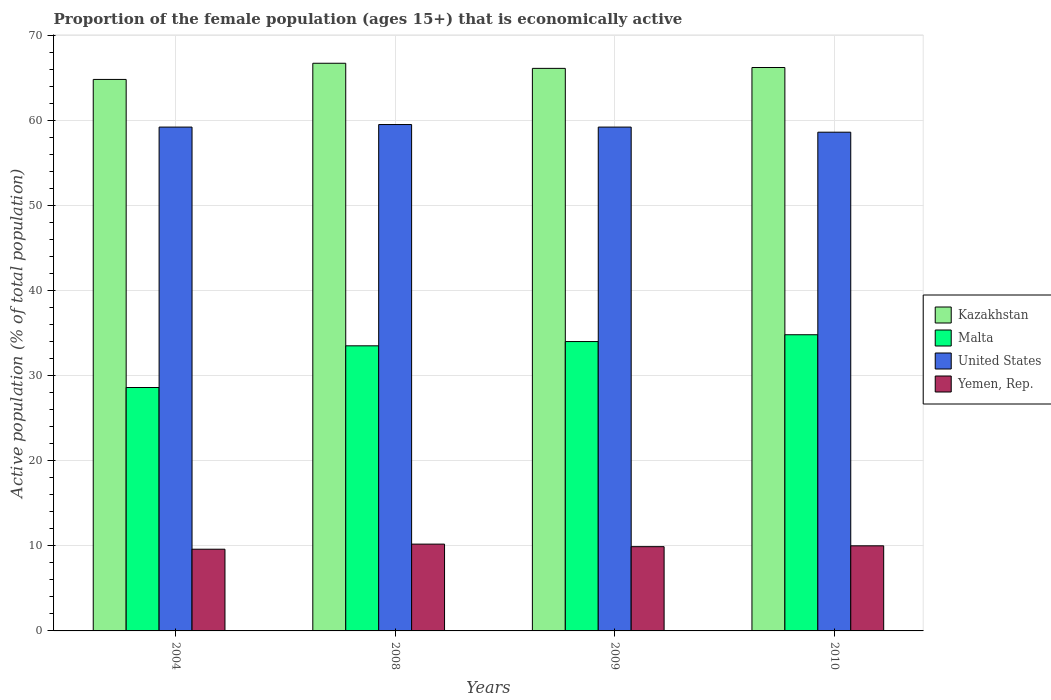How many different coloured bars are there?
Your response must be concise. 4. How many groups of bars are there?
Your response must be concise. 4. Are the number of bars per tick equal to the number of legend labels?
Give a very brief answer. Yes. Are the number of bars on each tick of the X-axis equal?
Your answer should be compact. Yes. How many bars are there on the 2nd tick from the right?
Your answer should be compact. 4. In how many cases, is the number of bars for a given year not equal to the number of legend labels?
Your answer should be very brief. 0. What is the proportion of the female population that is economically active in United States in 2008?
Offer a terse response. 59.5. Across all years, what is the maximum proportion of the female population that is economically active in Malta?
Offer a very short reply. 34.8. Across all years, what is the minimum proportion of the female population that is economically active in Kazakhstan?
Give a very brief answer. 64.8. What is the total proportion of the female population that is economically active in Yemen, Rep. in the graph?
Your answer should be compact. 39.7. What is the difference between the proportion of the female population that is economically active in Kazakhstan in 2009 and that in 2010?
Provide a short and direct response. -0.1. What is the difference between the proportion of the female population that is economically active in Malta in 2008 and the proportion of the female population that is economically active in United States in 2004?
Your answer should be compact. -25.7. What is the average proportion of the female population that is economically active in United States per year?
Your response must be concise. 59.13. In the year 2004, what is the difference between the proportion of the female population that is economically active in Malta and proportion of the female population that is economically active in Yemen, Rep.?
Offer a very short reply. 19. What is the ratio of the proportion of the female population that is economically active in Yemen, Rep. in 2008 to that in 2009?
Your response must be concise. 1.03. Is the difference between the proportion of the female population that is economically active in Malta in 2004 and 2008 greater than the difference between the proportion of the female population that is economically active in Yemen, Rep. in 2004 and 2008?
Give a very brief answer. No. What is the difference between the highest and the second highest proportion of the female population that is economically active in Malta?
Your answer should be compact. 0.8. What is the difference between the highest and the lowest proportion of the female population that is economically active in United States?
Make the answer very short. 0.9. In how many years, is the proportion of the female population that is economically active in Malta greater than the average proportion of the female population that is economically active in Malta taken over all years?
Keep it short and to the point. 3. Is the sum of the proportion of the female population that is economically active in Malta in 2004 and 2010 greater than the maximum proportion of the female population that is economically active in Yemen, Rep. across all years?
Provide a succinct answer. Yes. Is it the case that in every year, the sum of the proportion of the female population that is economically active in Kazakhstan and proportion of the female population that is economically active in Malta is greater than the sum of proportion of the female population that is economically active in Yemen, Rep. and proportion of the female population that is economically active in United States?
Keep it short and to the point. Yes. What does the 2nd bar from the left in 2010 represents?
Provide a short and direct response. Malta. What does the 2nd bar from the right in 2009 represents?
Make the answer very short. United States. Is it the case that in every year, the sum of the proportion of the female population that is economically active in Kazakhstan and proportion of the female population that is economically active in United States is greater than the proportion of the female population that is economically active in Malta?
Make the answer very short. Yes. Are all the bars in the graph horizontal?
Make the answer very short. No. Does the graph contain any zero values?
Your response must be concise. No. How many legend labels are there?
Provide a succinct answer. 4. How are the legend labels stacked?
Your answer should be compact. Vertical. What is the title of the graph?
Keep it short and to the point. Proportion of the female population (ages 15+) that is economically active. What is the label or title of the X-axis?
Offer a terse response. Years. What is the label or title of the Y-axis?
Offer a terse response. Active population (% of total population). What is the Active population (% of total population) in Kazakhstan in 2004?
Give a very brief answer. 64.8. What is the Active population (% of total population) of Malta in 2004?
Your answer should be very brief. 28.6. What is the Active population (% of total population) in United States in 2004?
Your answer should be compact. 59.2. What is the Active population (% of total population) in Yemen, Rep. in 2004?
Your response must be concise. 9.6. What is the Active population (% of total population) in Kazakhstan in 2008?
Provide a succinct answer. 66.7. What is the Active population (% of total population) in Malta in 2008?
Your answer should be compact. 33.5. What is the Active population (% of total population) in United States in 2008?
Your response must be concise. 59.5. What is the Active population (% of total population) of Yemen, Rep. in 2008?
Keep it short and to the point. 10.2. What is the Active population (% of total population) of Kazakhstan in 2009?
Your answer should be very brief. 66.1. What is the Active population (% of total population) of Malta in 2009?
Offer a terse response. 34. What is the Active population (% of total population) of United States in 2009?
Offer a terse response. 59.2. What is the Active population (% of total population) of Yemen, Rep. in 2009?
Provide a succinct answer. 9.9. What is the Active population (% of total population) of Kazakhstan in 2010?
Your response must be concise. 66.2. What is the Active population (% of total population) of Malta in 2010?
Offer a very short reply. 34.8. What is the Active population (% of total population) in United States in 2010?
Your answer should be compact. 58.6. What is the Active population (% of total population) in Yemen, Rep. in 2010?
Ensure brevity in your answer.  10. Across all years, what is the maximum Active population (% of total population) in Kazakhstan?
Provide a succinct answer. 66.7. Across all years, what is the maximum Active population (% of total population) of Malta?
Keep it short and to the point. 34.8. Across all years, what is the maximum Active population (% of total population) of United States?
Make the answer very short. 59.5. Across all years, what is the maximum Active population (% of total population) in Yemen, Rep.?
Your answer should be compact. 10.2. Across all years, what is the minimum Active population (% of total population) in Kazakhstan?
Your response must be concise. 64.8. Across all years, what is the minimum Active population (% of total population) of Malta?
Your answer should be compact. 28.6. Across all years, what is the minimum Active population (% of total population) in United States?
Provide a short and direct response. 58.6. Across all years, what is the minimum Active population (% of total population) in Yemen, Rep.?
Your answer should be very brief. 9.6. What is the total Active population (% of total population) in Kazakhstan in the graph?
Ensure brevity in your answer.  263.8. What is the total Active population (% of total population) in Malta in the graph?
Ensure brevity in your answer.  130.9. What is the total Active population (% of total population) in United States in the graph?
Keep it short and to the point. 236.5. What is the total Active population (% of total population) in Yemen, Rep. in the graph?
Your answer should be very brief. 39.7. What is the difference between the Active population (% of total population) in Kazakhstan in 2004 and that in 2008?
Give a very brief answer. -1.9. What is the difference between the Active population (% of total population) in United States in 2004 and that in 2008?
Keep it short and to the point. -0.3. What is the difference between the Active population (% of total population) of Yemen, Rep. in 2004 and that in 2008?
Provide a succinct answer. -0.6. What is the difference between the Active population (% of total population) in Malta in 2004 and that in 2009?
Ensure brevity in your answer.  -5.4. What is the difference between the Active population (% of total population) of United States in 2004 and that in 2009?
Offer a terse response. 0. What is the difference between the Active population (% of total population) in Yemen, Rep. in 2004 and that in 2009?
Your answer should be compact. -0.3. What is the difference between the Active population (% of total population) in Yemen, Rep. in 2004 and that in 2010?
Your answer should be compact. -0.4. What is the difference between the Active population (% of total population) in Kazakhstan in 2008 and that in 2009?
Ensure brevity in your answer.  0.6. What is the difference between the Active population (% of total population) in Malta in 2008 and that in 2009?
Keep it short and to the point. -0.5. What is the difference between the Active population (% of total population) of United States in 2008 and that in 2009?
Offer a very short reply. 0.3. What is the difference between the Active population (% of total population) in Yemen, Rep. in 2008 and that in 2009?
Keep it short and to the point. 0.3. What is the difference between the Active population (% of total population) of United States in 2008 and that in 2010?
Give a very brief answer. 0.9. What is the difference between the Active population (% of total population) of Kazakhstan in 2009 and that in 2010?
Make the answer very short. -0.1. What is the difference between the Active population (% of total population) of United States in 2009 and that in 2010?
Provide a succinct answer. 0.6. What is the difference between the Active population (% of total population) in Yemen, Rep. in 2009 and that in 2010?
Provide a short and direct response. -0.1. What is the difference between the Active population (% of total population) in Kazakhstan in 2004 and the Active population (% of total population) in Malta in 2008?
Ensure brevity in your answer.  31.3. What is the difference between the Active population (% of total population) in Kazakhstan in 2004 and the Active population (% of total population) in Yemen, Rep. in 2008?
Provide a succinct answer. 54.6. What is the difference between the Active population (% of total population) of Malta in 2004 and the Active population (% of total population) of United States in 2008?
Ensure brevity in your answer.  -30.9. What is the difference between the Active population (% of total population) in Kazakhstan in 2004 and the Active population (% of total population) in Malta in 2009?
Offer a very short reply. 30.8. What is the difference between the Active population (% of total population) of Kazakhstan in 2004 and the Active population (% of total population) of Yemen, Rep. in 2009?
Keep it short and to the point. 54.9. What is the difference between the Active population (% of total population) in Malta in 2004 and the Active population (% of total population) in United States in 2009?
Your answer should be very brief. -30.6. What is the difference between the Active population (% of total population) of Malta in 2004 and the Active population (% of total population) of Yemen, Rep. in 2009?
Give a very brief answer. 18.7. What is the difference between the Active population (% of total population) of United States in 2004 and the Active population (% of total population) of Yemen, Rep. in 2009?
Your answer should be very brief. 49.3. What is the difference between the Active population (% of total population) in Kazakhstan in 2004 and the Active population (% of total population) in Malta in 2010?
Your answer should be compact. 30. What is the difference between the Active population (% of total population) of Kazakhstan in 2004 and the Active population (% of total population) of United States in 2010?
Your response must be concise. 6.2. What is the difference between the Active population (% of total population) in Kazakhstan in 2004 and the Active population (% of total population) in Yemen, Rep. in 2010?
Provide a short and direct response. 54.8. What is the difference between the Active population (% of total population) of Malta in 2004 and the Active population (% of total population) of United States in 2010?
Offer a very short reply. -30. What is the difference between the Active population (% of total population) of Malta in 2004 and the Active population (% of total population) of Yemen, Rep. in 2010?
Your answer should be very brief. 18.6. What is the difference between the Active population (% of total population) of United States in 2004 and the Active population (% of total population) of Yemen, Rep. in 2010?
Provide a succinct answer. 49.2. What is the difference between the Active population (% of total population) of Kazakhstan in 2008 and the Active population (% of total population) of Malta in 2009?
Your answer should be compact. 32.7. What is the difference between the Active population (% of total population) in Kazakhstan in 2008 and the Active population (% of total population) in Yemen, Rep. in 2009?
Provide a short and direct response. 56.8. What is the difference between the Active population (% of total population) in Malta in 2008 and the Active population (% of total population) in United States in 2009?
Your answer should be very brief. -25.7. What is the difference between the Active population (% of total population) of Malta in 2008 and the Active population (% of total population) of Yemen, Rep. in 2009?
Offer a very short reply. 23.6. What is the difference between the Active population (% of total population) in United States in 2008 and the Active population (% of total population) in Yemen, Rep. in 2009?
Provide a succinct answer. 49.6. What is the difference between the Active population (% of total population) in Kazakhstan in 2008 and the Active population (% of total population) in Malta in 2010?
Your response must be concise. 31.9. What is the difference between the Active population (% of total population) of Kazakhstan in 2008 and the Active population (% of total population) of Yemen, Rep. in 2010?
Offer a very short reply. 56.7. What is the difference between the Active population (% of total population) of Malta in 2008 and the Active population (% of total population) of United States in 2010?
Provide a succinct answer. -25.1. What is the difference between the Active population (% of total population) in United States in 2008 and the Active population (% of total population) in Yemen, Rep. in 2010?
Provide a succinct answer. 49.5. What is the difference between the Active population (% of total population) in Kazakhstan in 2009 and the Active population (% of total population) in Malta in 2010?
Give a very brief answer. 31.3. What is the difference between the Active population (% of total population) of Kazakhstan in 2009 and the Active population (% of total population) of Yemen, Rep. in 2010?
Your answer should be very brief. 56.1. What is the difference between the Active population (% of total population) in Malta in 2009 and the Active population (% of total population) in United States in 2010?
Make the answer very short. -24.6. What is the difference between the Active population (% of total population) of Malta in 2009 and the Active population (% of total population) of Yemen, Rep. in 2010?
Offer a very short reply. 24. What is the difference between the Active population (% of total population) of United States in 2009 and the Active population (% of total population) of Yemen, Rep. in 2010?
Ensure brevity in your answer.  49.2. What is the average Active population (% of total population) in Kazakhstan per year?
Your answer should be compact. 65.95. What is the average Active population (% of total population) in Malta per year?
Your answer should be compact. 32.73. What is the average Active population (% of total population) in United States per year?
Provide a succinct answer. 59.12. What is the average Active population (% of total population) of Yemen, Rep. per year?
Keep it short and to the point. 9.93. In the year 2004, what is the difference between the Active population (% of total population) in Kazakhstan and Active population (% of total population) in Malta?
Provide a short and direct response. 36.2. In the year 2004, what is the difference between the Active population (% of total population) in Kazakhstan and Active population (% of total population) in United States?
Offer a terse response. 5.6. In the year 2004, what is the difference between the Active population (% of total population) of Kazakhstan and Active population (% of total population) of Yemen, Rep.?
Your answer should be very brief. 55.2. In the year 2004, what is the difference between the Active population (% of total population) of Malta and Active population (% of total population) of United States?
Offer a very short reply. -30.6. In the year 2004, what is the difference between the Active population (% of total population) of Malta and Active population (% of total population) of Yemen, Rep.?
Keep it short and to the point. 19. In the year 2004, what is the difference between the Active population (% of total population) of United States and Active population (% of total population) of Yemen, Rep.?
Provide a succinct answer. 49.6. In the year 2008, what is the difference between the Active population (% of total population) in Kazakhstan and Active population (% of total population) in Malta?
Your response must be concise. 33.2. In the year 2008, what is the difference between the Active population (% of total population) in Kazakhstan and Active population (% of total population) in Yemen, Rep.?
Give a very brief answer. 56.5. In the year 2008, what is the difference between the Active population (% of total population) of Malta and Active population (% of total population) of Yemen, Rep.?
Your response must be concise. 23.3. In the year 2008, what is the difference between the Active population (% of total population) in United States and Active population (% of total population) in Yemen, Rep.?
Offer a very short reply. 49.3. In the year 2009, what is the difference between the Active population (% of total population) in Kazakhstan and Active population (% of total population) in Malta?
Give a very brief answer. 32.1. In the year 2009, what is the difference between the Active population (% of total population) in Kazakhstan and Active population (% of total population) in United States?
Give a very brief answer. 6.9. In the year 2009, what is the difference between the Active population (% of total population) in Kazakhstan and Active population (% of total population) in Yemen, Rep.?
Ensure brevity in your answer.  56.2. In the year 2009, what is the difference between the Active population (% of total population) of Malta and Active population (% of total population) of United States?
Give a very brief answer. -25.2. In the year 2009, what is the difference between the Active population (% of total population) of Malta and Active population (% of total population) of Yemen, Rep.?
Offer a terse response. 24.1. In the year 2009, what is the difference between the Active population (% of total population) of United States and Active population (% of total population) of Yemen, Rep.?
Give a very brief answer. 49.3. In the year 2010, what is the difference between the Active population (% of total population) in Kazakhstan and Active population (% of total population) in Malta?
Offer a terse response. 31.4. In the year 2010, what is the difference between the Active population (% of total population) of Kazakhstan and Active population (% of total population) of United States?
Your answer should be compact. 7.6. In the year 2010, what is the difference between the Active population (% of total population) of Kazakhstan and Active population (% of total population) of Yemen, Rep.?
Provide a succinct answer. 56.2. In the year 2010, what is the difference between the Active population (% of total population) in Malta and Active population (% of total population) in United States?
Give a very brief answer. -23.8. In the year 2010, what is the difference between the Active population (% of total population) in Malta and Active population (% of total population) in Yemen, Rep.?
Your answer should be compact. 24.8. In the year 2010, what is the difference between the Active population (% of total population) in United States and Active population (% of total population) in Yemen, Rep.?
Provide a succinct answer. 48.6. What is the ratio of the Active population (% of total population) in Kazakhstan in 2004 to that in 2008?
Give a very brief answer. 0.97. What is the ratio of the Active population (% of total population) of Malta in 2004 to that in 2008?
Your answer should be compact. 0.85. What is the ratio of the Active population (% of total population) in Yemen, Rep. in 2004 to that in 2008?
Your answer should be compact. 0.94. What is the ratio of the Active population (% of total population) of Kazakhstan in 2004 to that in 2009?
Keep it short and to the point. 0.98. What is the ratio of the Active population (% of total population) of Malta in 2004 to that in 2009?
Your response must be concise. 0.84. What is the ratio of the Active population (% of total population) of United States in 2004 to that in 2009?
Keep it short and to the point. 1. What is the ratio of the Active population (% of total population) of Yemen, Rep. in 2004 to that in 2009?
Ensure brevity in your answer.  0.97. What is the ratio of the Active population (% of total population) of Kazakhstan in 2004 to that in 2010?
Your answer should be very brief. 0.98. What is the ratio of the Active population (% of total population) in Malta in 2004 to that in 2010?
Your response must be concise. 0.82. What is the ratio of the Active population (% of total population) in United States in 2004 to that in 2010?
Provide a short and direct response. 1.01. What is the ratio of the Active population (% of total population) in Yemen, Rep. in 2004 to that in 2010?
Offer a terse response. 0.96. What is the ratio of the Active population (% of total population) in Kazakhstan in 2008 to that in 2009?
Offer a very short reply. 1.01. What is the ratio of the Active population (% of total population) of United States in 2008 to that in 2009?
Ensure brevity in your answer.  1.01. What is the ratio of the Active population (% of total population) in Yemen, Rep. in 2008 to that in 2009?
Your answer should be compact. 1.03. What is the ratio of the Active population (% of total population) of Kazakhstan in 2008 to that in 2010?
Provide a succinct answer. 1.01. What is the ratio of the Active population (% of total population) of Malta in 2008 to that in 2010?
Make the answer very short. 0.96. What is the ratio of the Active population (% of total population) in United States in 2008 to that in 2010?
Your answer should be very brief. 1.02. What is the ratio of the Active population (% of total population) of Malta in 2009 to that in 2010?
Ensure brevity in your answer.  0.98. What is the ratio of the Active population (% of total population) of United States in 2009 to that in 2010?
Ensure brevity in your answer.  1.01. What is the ratio of the Active population (% of total population) of Yemen, Rep. in 2009 to that in 2010?
Give a very brief answer. 0.99. What is the difference between the highest and the second highest Active population (% of total population) of Kazakhstan?
Provide a short and direct response. 0.5. What is the difference between the highest and the lowest Active population (% of total population) in Kazakhstan?
Offer a terse response. 1.9. What is the difference between the highest and the lowest Active population (% of total population) of United States?
Give a very brief answer. 0.9. 